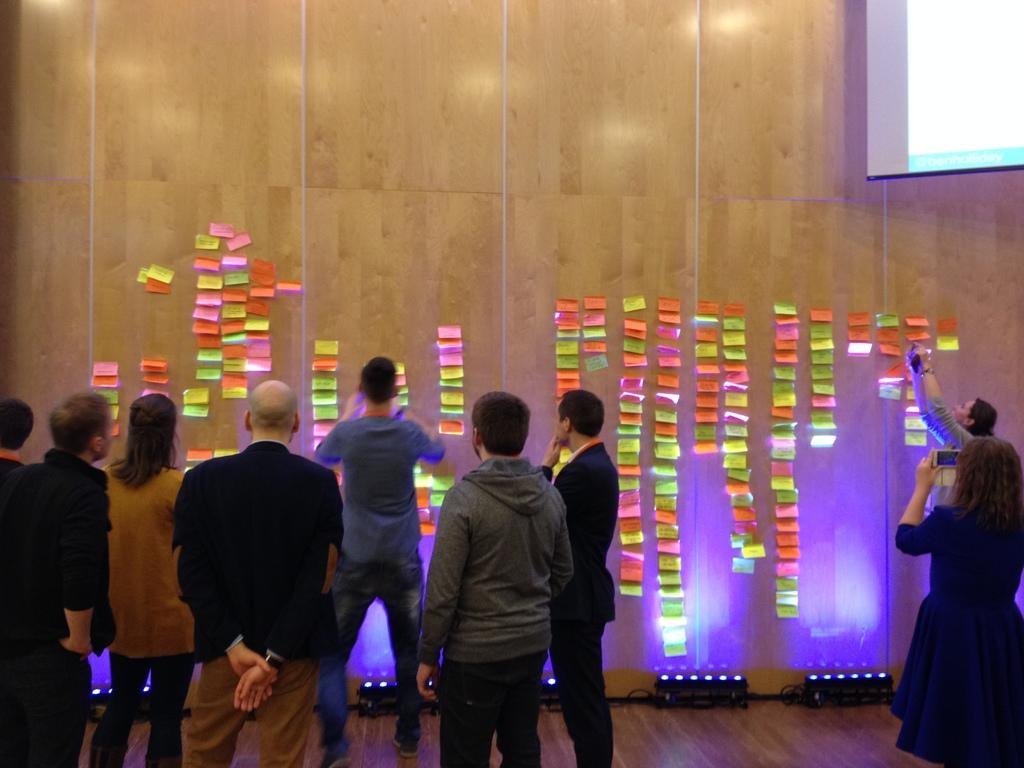What is happening in the image? There are people standing in the image. Can you describe the background of the image? There is something on the wall in the background of the image. What type of horse can be seen on the side of the image? There is no horse present in the image. Can you describe the skateboarding activity happening in the image? There is no skateboarding activity happening in the image; it only shows people standing. 